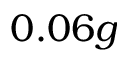<formula> <loc_0><loc_0><loc_500><loc_500>0 . 0 6 g</formula> 